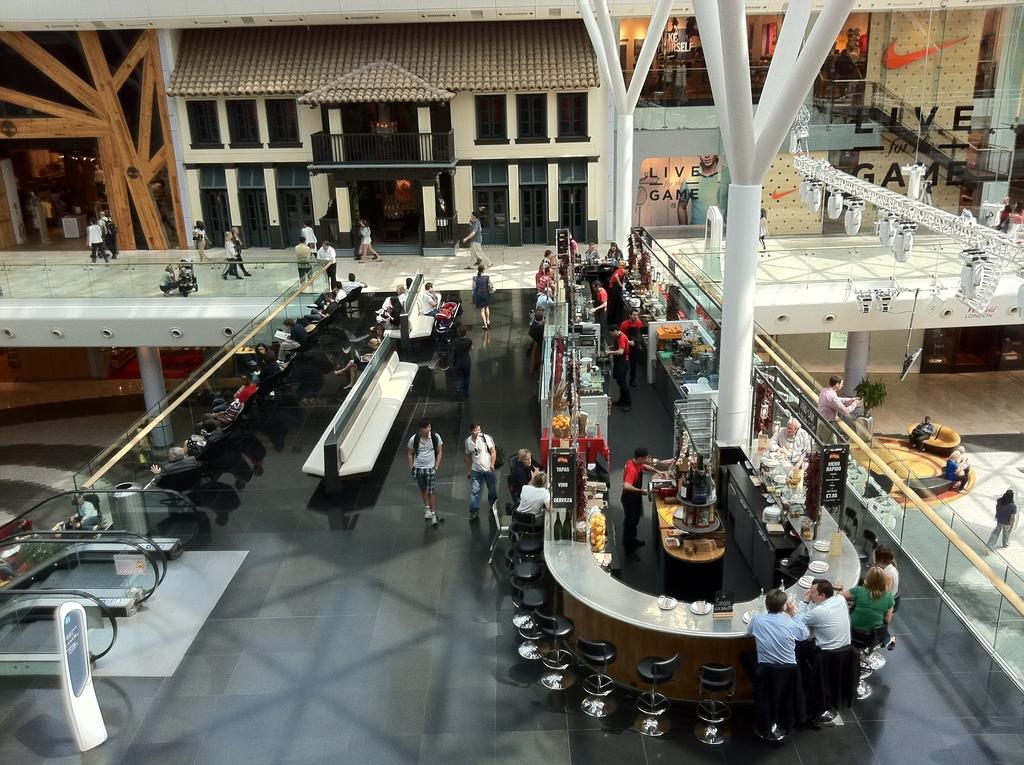What type of structures can be seen in the image? There are buildings in the image. Who or what is present in the image besides the buildings? There are people in the image. What type of furniture is visible in the image? There are chairs in the image. Are there any moving elements in the image? Yes, there are escalators in the image. What type of illumination is present in the image? There are lights in the image. What architectural features can be seen in the image? There are pillars in the image. What type of barrier is present in the image? There is a railing in the image. What type of seating is present in the image? There is a bench in the image. How many bottles of water are visible on the bench in the image? There are no bottles of water present in the image. What type of snakes can be seen slithering on the railing in the image? There are no snakes present in the image. Is there a bath visible in the image? There is no bath present in the image. 